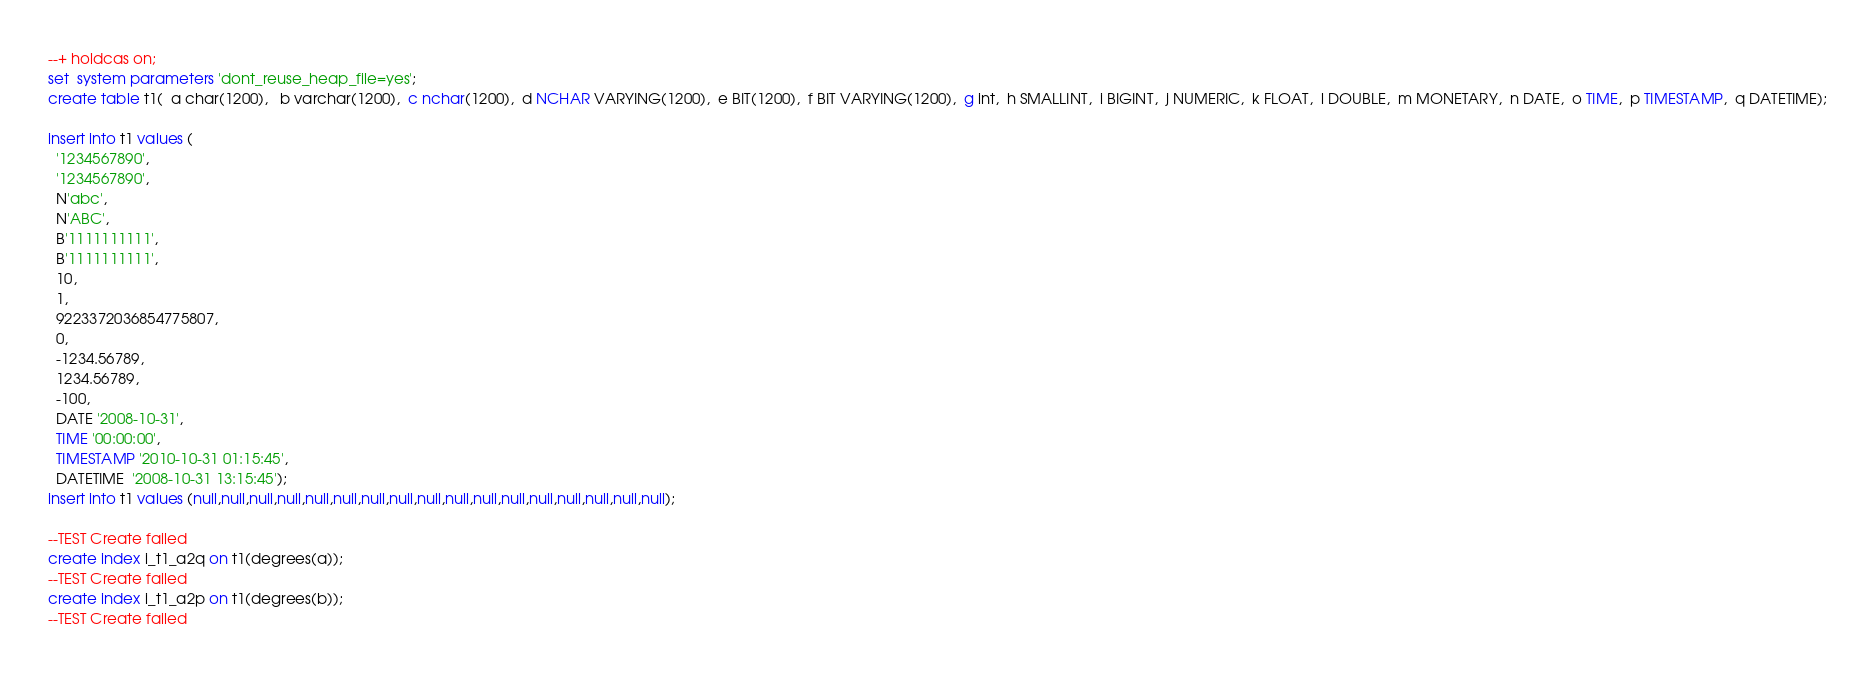Convert code to text. <code><loc_0><loc_0><loc_500><loc_500><_SQL_>--+ holdcas on;
set  system parameters 'dont_reuse_heap_file=yes';
create table t1(  a char(1200),   b varchar(1200),  c nchar(1200),  d NCHAR VARYING(1200),  e BIT(1200),  f BIT VARYING(1200),  g int,  h SMALLINT,  i BIGINT,  j NUMERIC,  k FLOAT,  l DOUBLE,  m MONETARY,  n DATE,  o TIME,  p TIMESTAMP,  q DATETIME);

insert into t1 values (
  '1234567890',
  '1234567890',
  N'abc',
  N'ABC',
  B'1111111111',
  B'1111111111',
  10,
  1,
  9223372036854775807,
  0,
  -1234.56789,
  1234.56789,
  -100,
  DATE '2008-10-31',
  TIME '00:00:00',
  TIMESTAMP '2010-10-31 01:15:45',
  DATETIME  '2008-10-31 13:15:45');
insert into t1 values (null,null,null,null,null,null,null,null,null,null,null,null,null,null,null,null,null);

--TEST Create failed 
create index i_t1_a2q on t1(degrees(a));
--TEST Create failed 
create index i_t1_a2p on t1(degrees(b));
--TEST Create failed </code> 